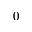Convert formula to latex. <formula><loc_0><loc_0><loc_500><loc_500>0</formula> 